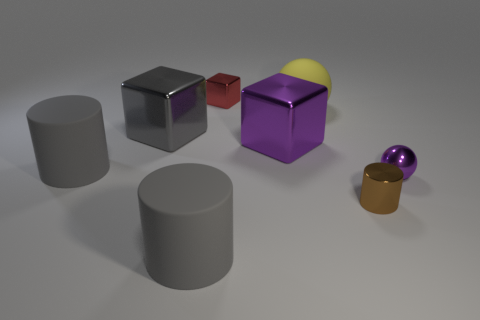Is the color of the small metal ball the same as the small shiny cylinder?
Ensure brevity in your answer.  No. What number of small red cubes are in front of the red cube?
Keep it short and to the point. 0. How many matte things are in front of the big yellow sphere and behind the purple ball?
Your answer should be compact. 1. The small red thing that is made of the same material as the big purple cube is what shape?
Your response must be concise. Cube. There is a purple shiny object on the right side of the yellow ball; is its size the same as the purple block to the left of the small metal sphere?
Offer a terse response. No. What is the color of the tiny metallic thing right of the small brown metal thing?
Provide a succinct answer. Purple. The purple ball in front of the large block that is on the right side of the tiny red metal thing is made of what material?
Your response must be concise. Metal. The small red metal object has what shape?
Your answer should be very brief. Cube. There is another thing that is the same shape as the small purple object; what is its material?
Offer a terse response. Rubber. How many purple shiny balls have the same size as the red metal block?
Give a very brief answer. 1. 